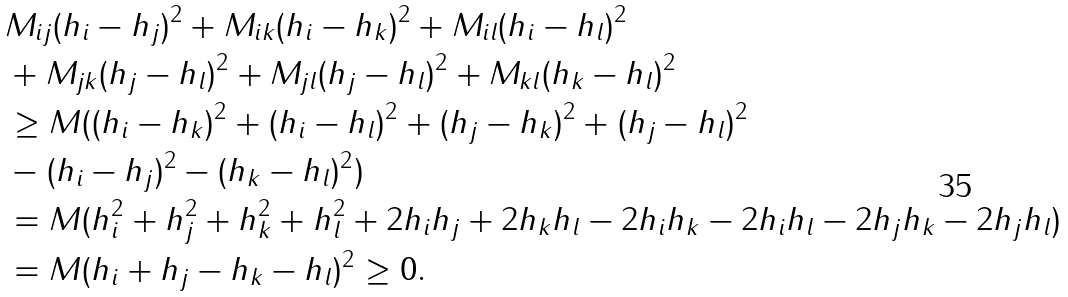<formula> <loc_0><loc_0><loc_500><loc_500>& M _ { i j } ( h _ { i } - h _ { j } ) ^ { 2 } + M _ { i k } ( h _ { i } - h _ { k } ) ^ { 2 } + M _ { i l } ( h _ { i } - h _ { l } ) ^ { 2 } \\ & + M _ { j k } ( h _ { j } - h _ { l } ) ^ { 2 } + M _ { j l } ( h _ { j } - h _ { l } ) ^ { 2 } + M _ { k l } ( h _ { k } - h _ { l } ) ^ { 2 } \\ & \geq M ( ( h _ { i } - h _ { k } ) ^ { 2 } + ( h _ { i } - h _ { l } ) ^ { 2 } + ( h _ { j } - h _ { k } ) ^ { 2 } + ( h _ { j } - h _ { l } ) ^ { 2 } \\ & - ( h _ { i } - h _ { j } ) ^ { 2 } - ( h _ { k } - h _ { l } ) ^ { 2 } ) \\ & = M ( h _ { i } ^ { 2 } + h _ { j } ^ { 2 } + h _ { k } ^ { 2 } + h _ { l } ^ { 2 } + 2 h _ { i } h _ { j } + 2 h _ { k } h _ { l } - 2 h _ { i } h _ { k } - 2 h _ { i } h _ { l } - 2 h _ { j } h _ { k } - 2 h _ { j } h _ { l } ) \\ & = M ( h _ { i } + h _ { j } - h _ { k } - h _ { l } ) ^ { 2 } \geq 0 .</formula> 